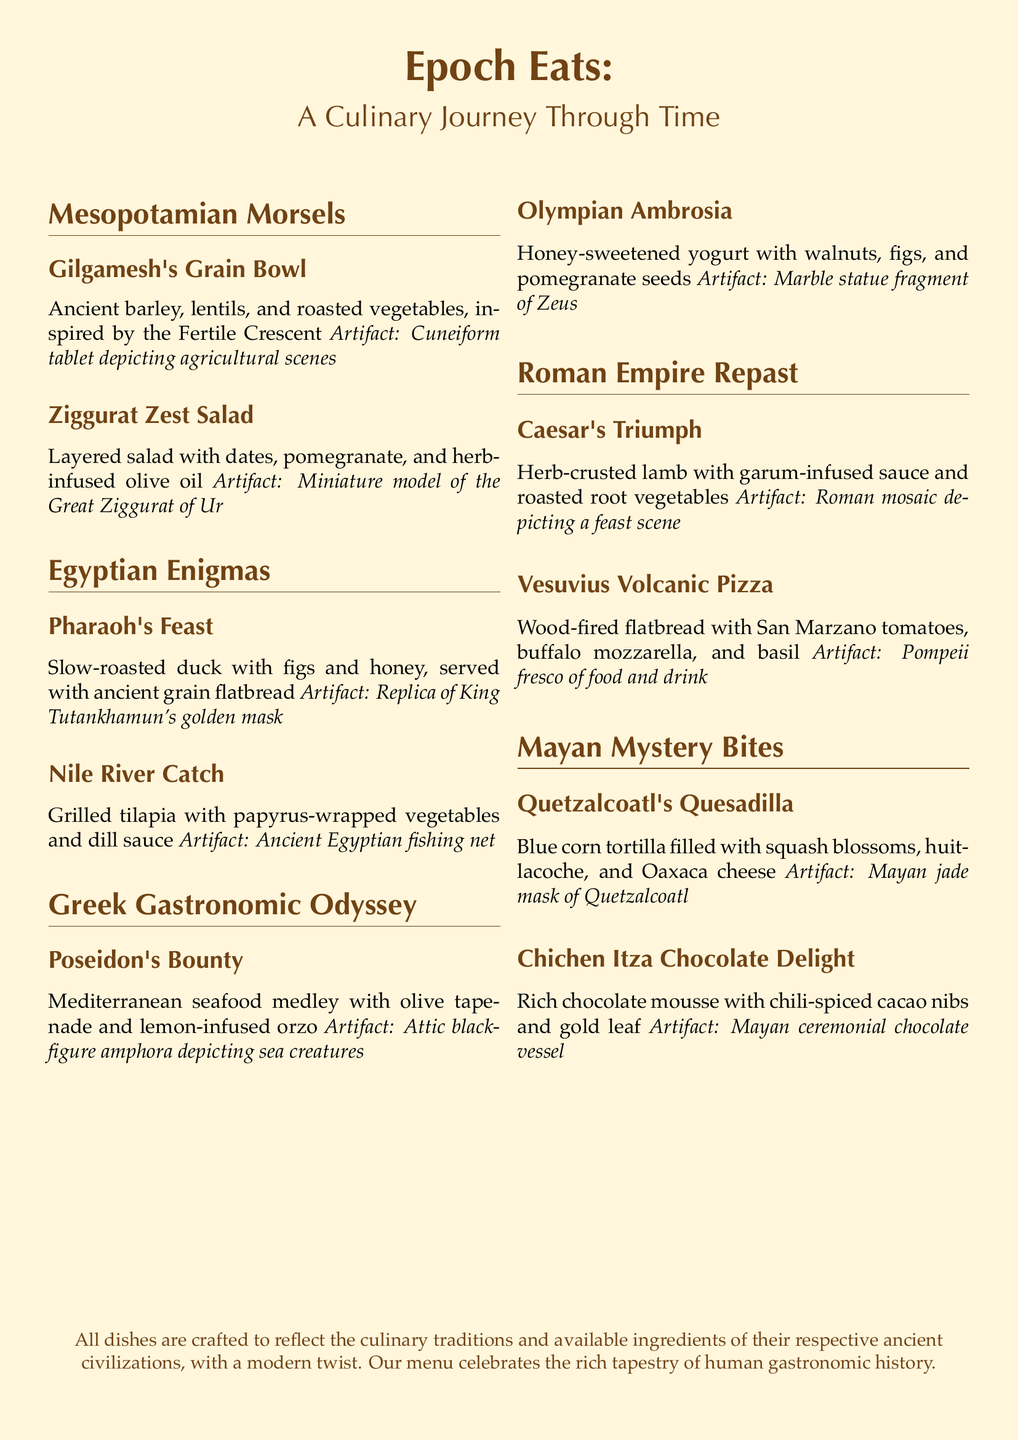What is the name of the restaurant? The name of the restaurant, as stated at the beginning of the document, is "Epoch Eats."
Answer: Epoch Eats What ancient civilization inspires the "Pharaoh's Feast"? The dish "Pharaoh's Feast" is inspired by the ancient Egyptian civilization.
Answer: Egyptian What is the main ingredient of the "Ziggurat Zest Salad"? The "Ziggurat Zest Salad" features dates as one of its main ingredients.
Answer: Dates Which artifact accompanies the "Vesuvius Volcanic Pizza"? The artifact associated with the "Vesuvius Volcanic Pizza" is a Pompeii fresco of food and drink.
Answer: Pompeii fresco What type of tortilla is used in "Quetzalcoatl's Quesadilla"? The document specifies that blue corn tortillas are used in "Quetzalcoatl's Quesadilla."
Answer: Blue corn Which dish includes a chocolate element? The dish that includes a chocolate element is "Chichen Itza Chocolate Delight."
Answer: Chichen Itza Chocolate Delight What kind of meat is in "Caesar's Triumph"? "Caesar's Triumph" features herb-crusted lamb as its meat.
Answer: Lamb How many sections are there in the menu? The menu contains five sections corresponding to different ancient civilizations.
Answer: Five 